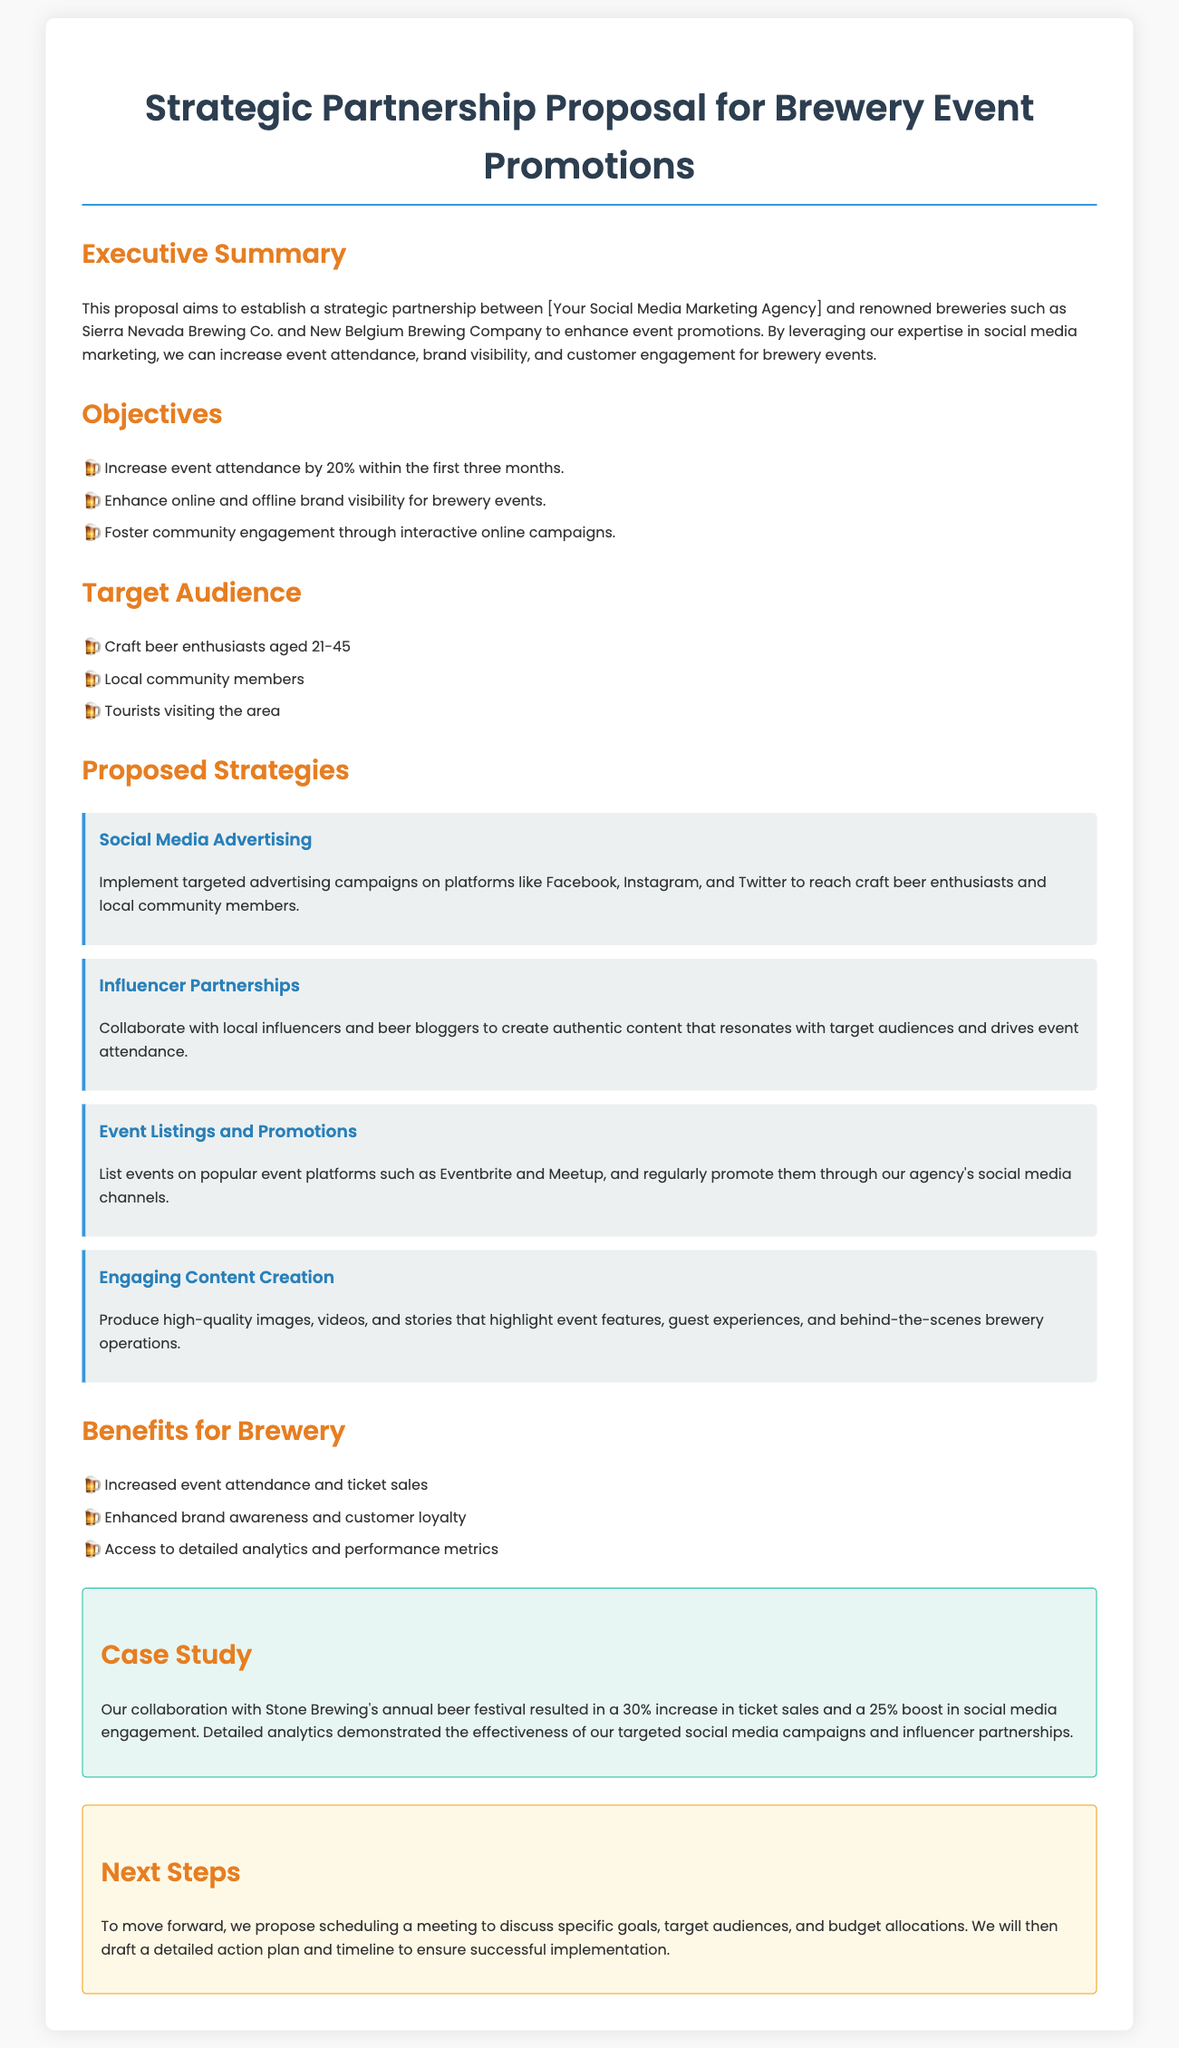What is the primary goal of the proposal? The primary goal of the proposal is to establish a strategic partnership for enhancing event promotions for breweries.
Answer: Enhance event promotions What is the target audience age range? The target audience specifically mentions craft beer enthusiasts aged 21-45.
Answer: 21-45 By what percentage does the proposal aim to increase event attendance? The proposal states it aims to increase event attendance by 20% within the first three months.
Answer: 20% What is one proposed strategy mentioned in the document? The document lists several strategies, one of which is social media advertising targeted at specific audiences.
Answer: Social Media Advertising What is the outcome of the case study with Stone Brewing? The collaboration resulted in a 30% increase in ticket sales for the beer festival.
Answer: 30% What type of marketing does the proposal focus on? The proposal emphasizes social media marketing as the core strategy for event promotions.
Answer: Social media marketing Which breweries are mentioned as potential partners? The proposal mentions Sierra Nevada Brewing Co. and New Belgium Brewing Company as potential partners.
Answer: Sierra Nevada Brewing Co. and New Belgium Brewing Company What is one benefit for the brewery according to the proposal? One benefit stated in the proposal is increased event attendance and ticket sales.
Answer: Increased event attendance and ticket sales What is the recommended next step in the proposal? The recommended next step is to schedule a meeting to discuss specific goals and budgets.
Answer: Schedule a meeting 